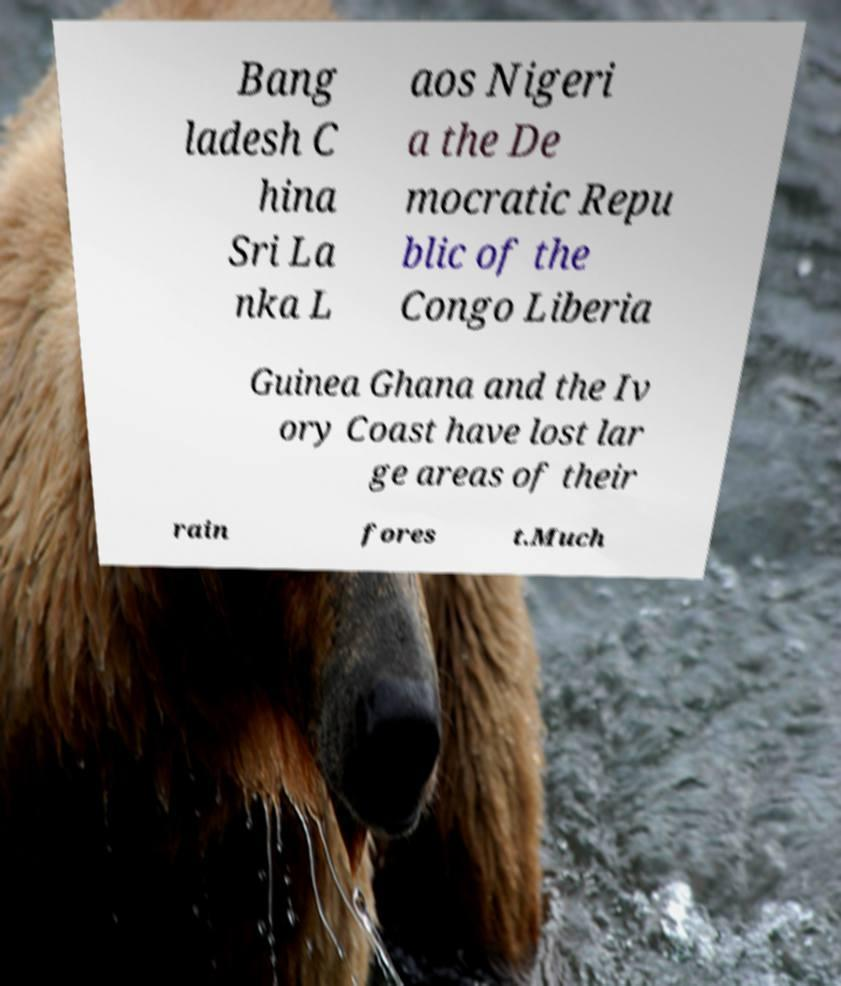For documentation purposes, I need the text within this image transcribed. Could you provide that? Bang ladesh C hina Sri La nka L aos Nigeri a the De mocratic Repu blic of the Congo Liberia Guinea Ghana and the Iv ory Coast have lost lar ge areas of their rain fores t.Much 